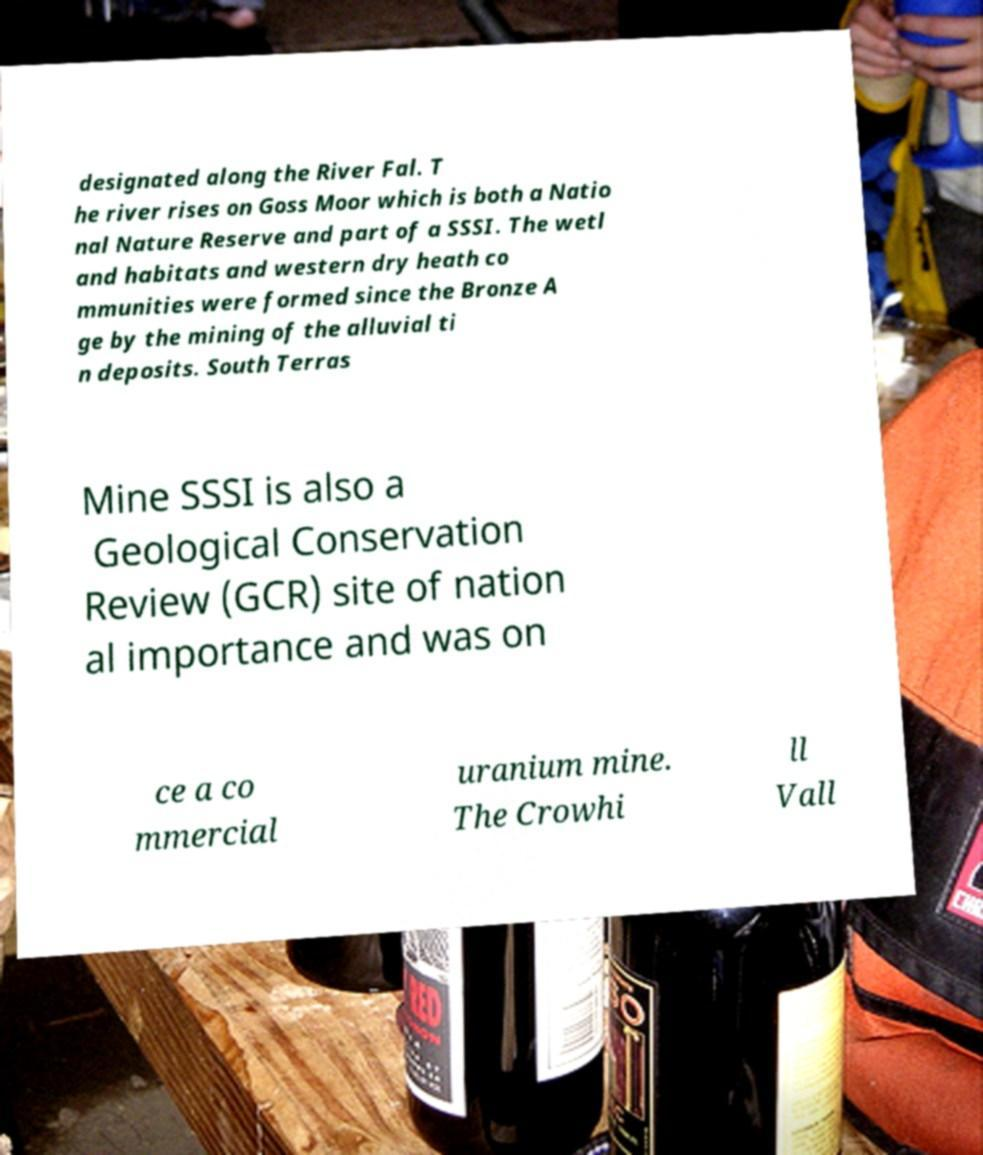For documentation purposes, I need the text within this image transcribed. Could you provide that? designated along the River Fal. T he river rises on Goss Moor which is both a Natio nal Nature Reserve and part of a SSSI. The wetl and habitats and western dry heath co mmunities were formed since the Bronze A ge by the mining of the alluvial ti n deposits. South Terras Mine SSSI is also a Geological Conservation Review (GCR) site of nation al importance and was on ce a co mmercial uranium mine. The Crowhi ll Vall 